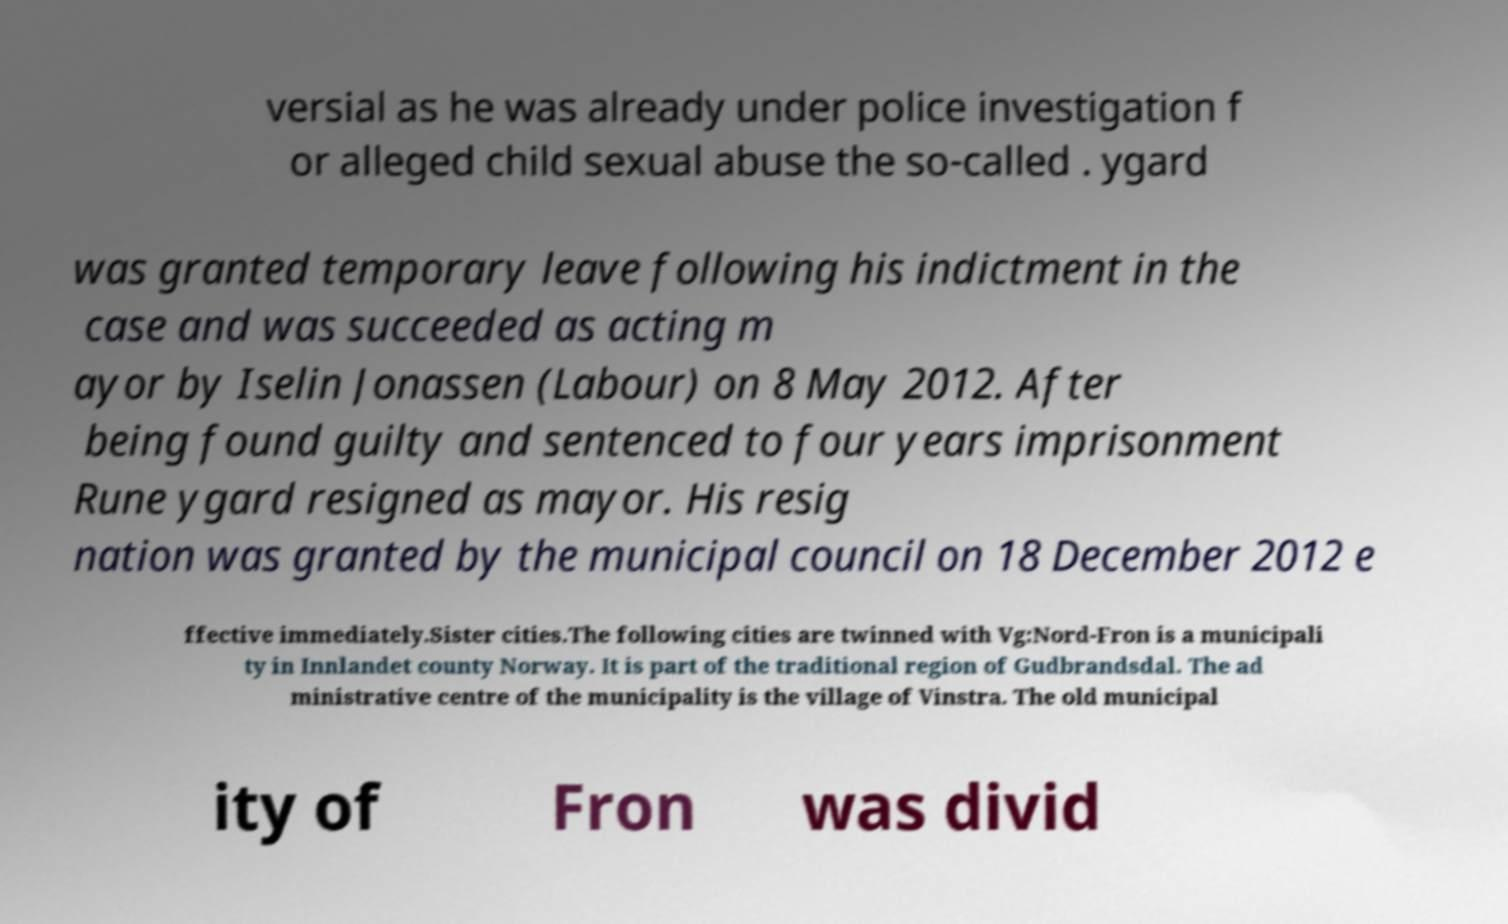What messages or text are displayed in this image? I need them in a readable, typed format. versial as he was already under police investigation f or alleged child sexual abuse the so-called . ygard was granted temporary leave following his indictment in the case and was succeeded as acting m ayor by Iselin Jonassen (Labour) on 8 May 2012. After being found guilty and sentenced to four years imprisonment Rune ygard resigned as mayor. His resig nation was granted by the municipal council on 18 December 2012 e ffective immediately.Sister cities.The following cities are twinned with Vg:Nord-Fron is a municipali ty in Innlandet county Norway. It is part of the traditional region of Gudbrandsdal. The ad ministrative centre of the municipality is the village of Vinstra. The old municipal ity of Fron was divid 